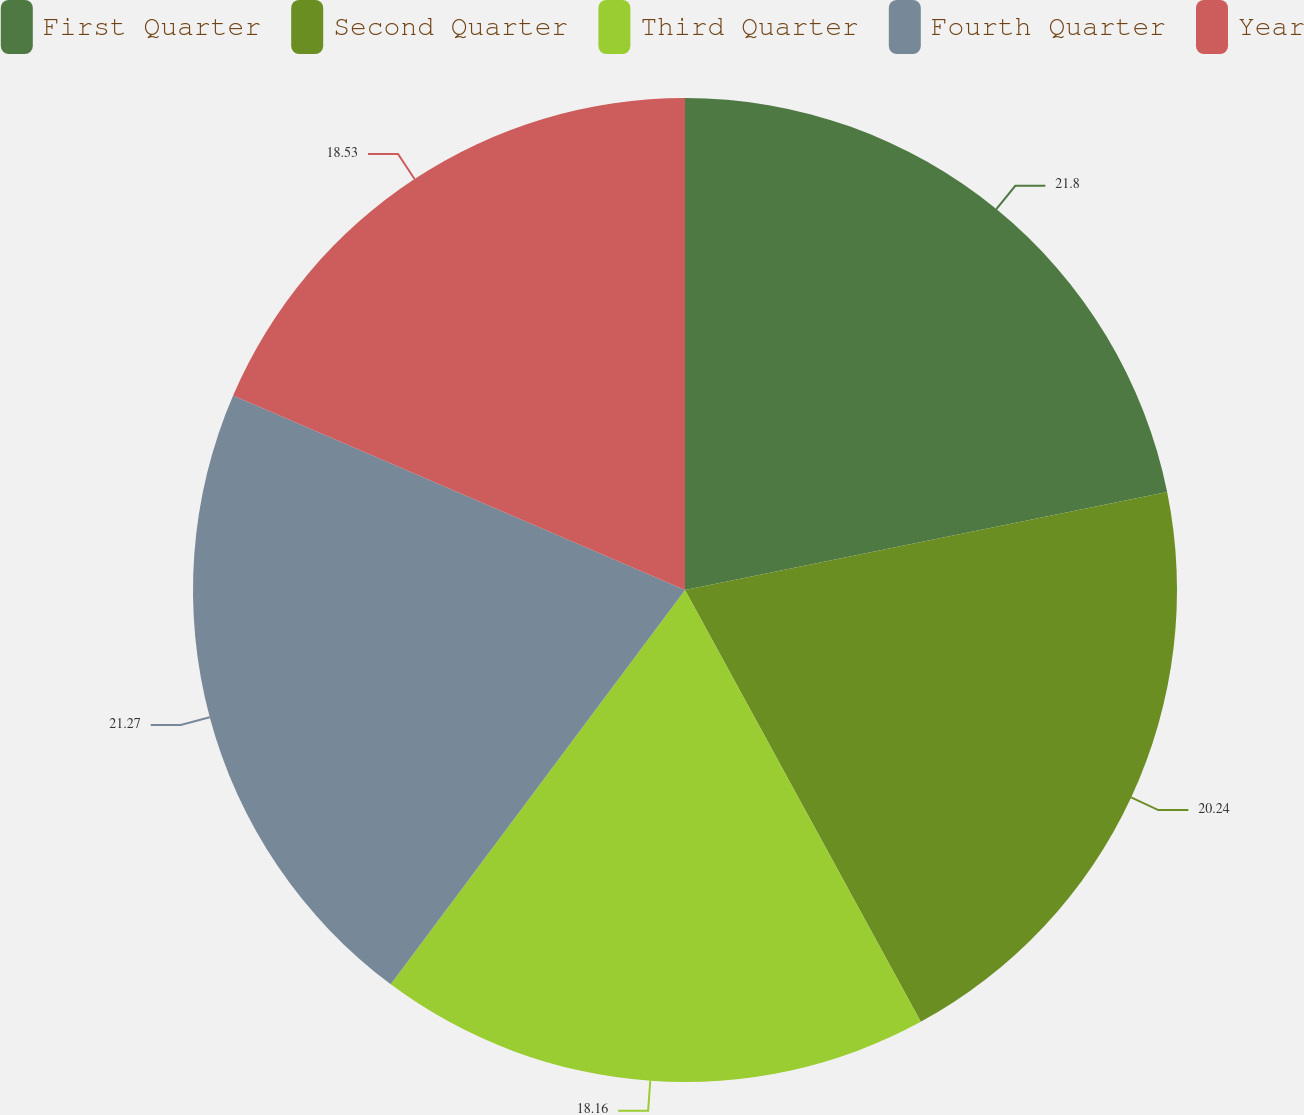Convert chart to OTSL. <chart><loc_0><loc_0><loc_500><loc_500><pie_chart><fcel>First Quarter<fcel>Second Quarter<fcel>Third Quarter<fcel>Fourth Quarter<fcel>Year<nl><fcel>21.81%<fcel>20.24%<fcel>18.16%<fcel>21.27%<fcel>18.53%<nl></chart> 